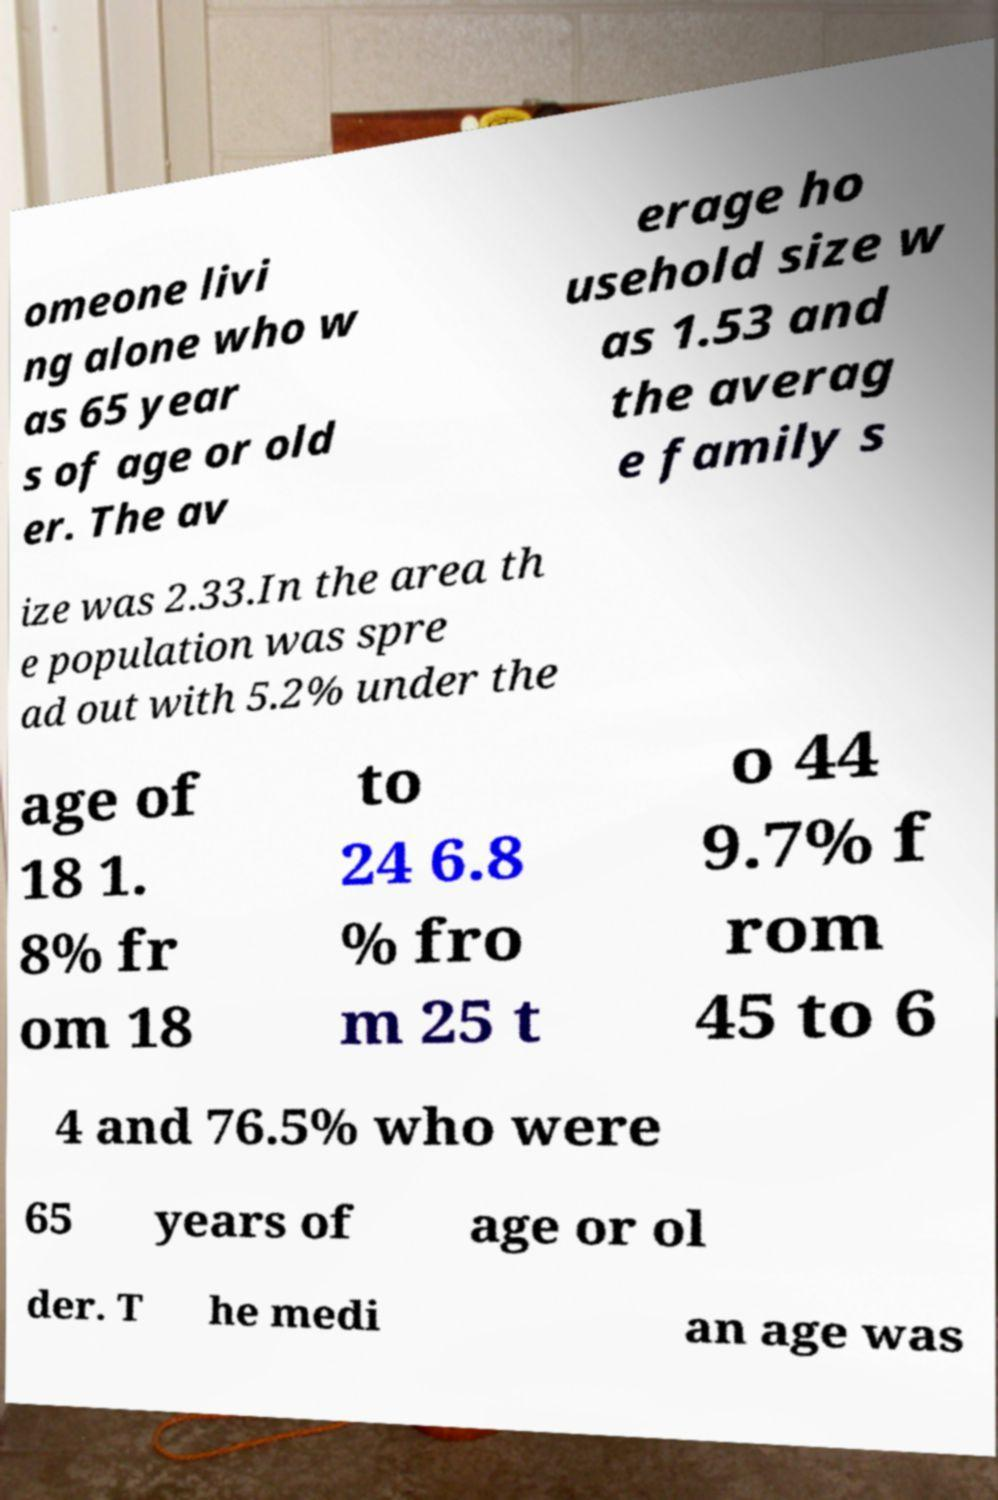What messages or text are displayed in this image? I need them in a readable, typed format. omeone livi ng alone who w as 65 year s of age or old er. The av erage ho usehold size w as 1.53 and the averag e family s ize was 2.33.In the area th e population was spre ad out with 5.2% under the age of 18 1. 8% fr om 18 to 24 6.8 % fro m 25 t o 44 9.7% f rom 45 to 6 4 and 76.5% who were 65 years of age or ol der. T he medi an age was 